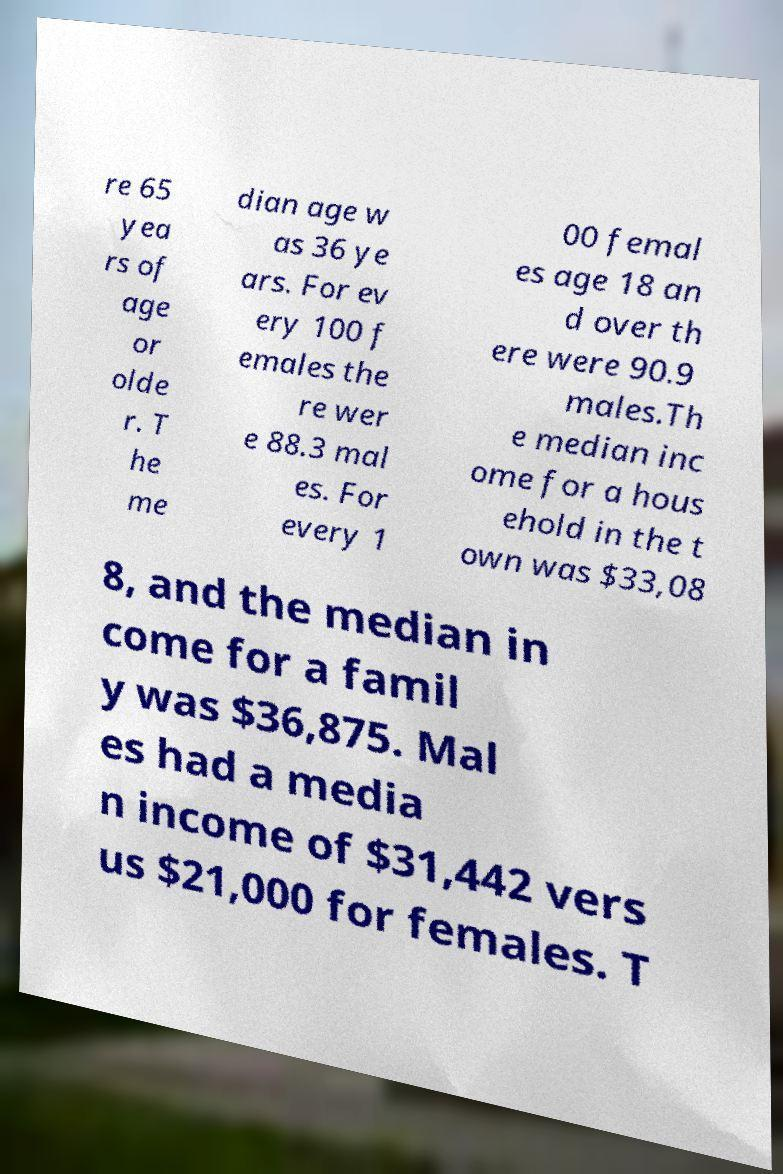Could you extract and type out the text from this image? re 65 yea rs of age or olde r. T he me dian age w as 36 ye ars. For ev ery 100 f emales the re wer e 88.3 mal es. For every 1 00 femal es age 18 an d over th ere were 90.9 males.Th e median inc ome for a hous ehold in the t own was $33,08 8, and the median in come for a famil y was $36,875. Mal es had a media n income of $31,442 vers us $21,000 for females. T 